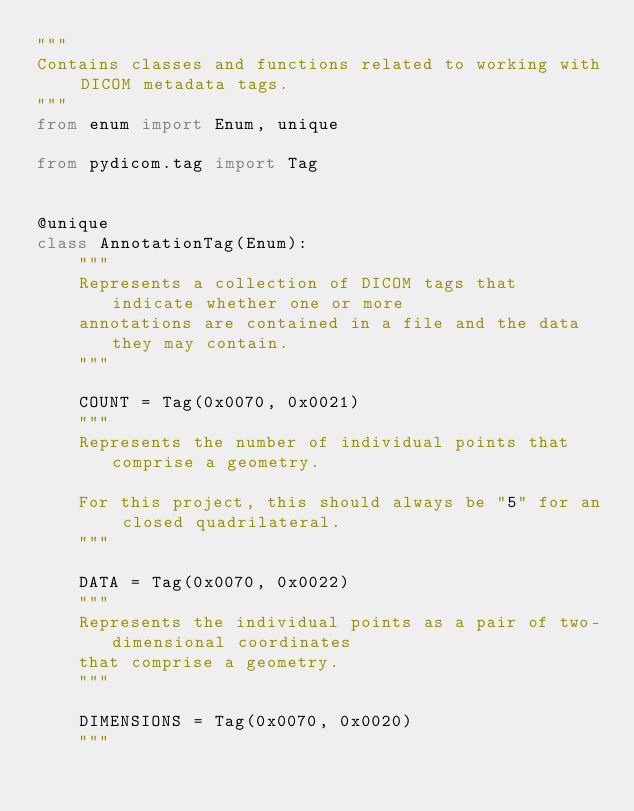<code> <loc_0><loc_0><loc_500><loc_500><_Python_>"""
Contains classes and functions related to working with DICOM metadata tags.
"""
from enum import Enum, unique

from pydicom.tag import Tag


@unique
class AnnotationTag(Enum):
    """
    Represents a collection of DICOM tags that indicate whether one or more
    annotations are contained in a file and the data they may contain.
    """

    COUNT = Tag(0x0070, 0x0021)
    """
    Represents the number of individual points that comprise a geometry.
    
    For this project, this should always be "5" for an closed quadrilateral.
    """

    DATA = Tag(0x0070, 0x0022)
    """
    Represents the individual points as a pair of two-dimensional coordinates 
    that comprise a geometry.    
    """

    DIMENSIONS = Tag(0x0070, 0x0020)
    """</code> 